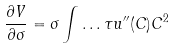<formula> <loc_0><loc_0><loc_500><loc_500>\frac { \partial V } { \partial \sigma } = \sigma \int \dots \tau u ^ { \prime \prime } ( C ) C ^ { 2 }</formula> 